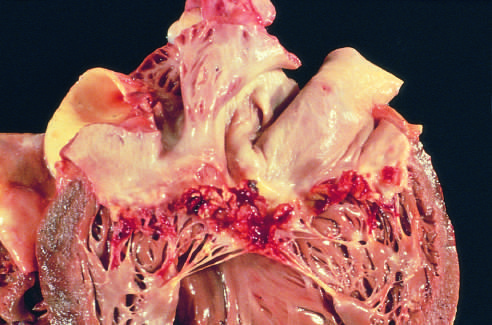how is subacute endocarditis caused?
Answer the question using a single word or phrase. By streptococcus viridans on a previously myxomatous mitral valve 